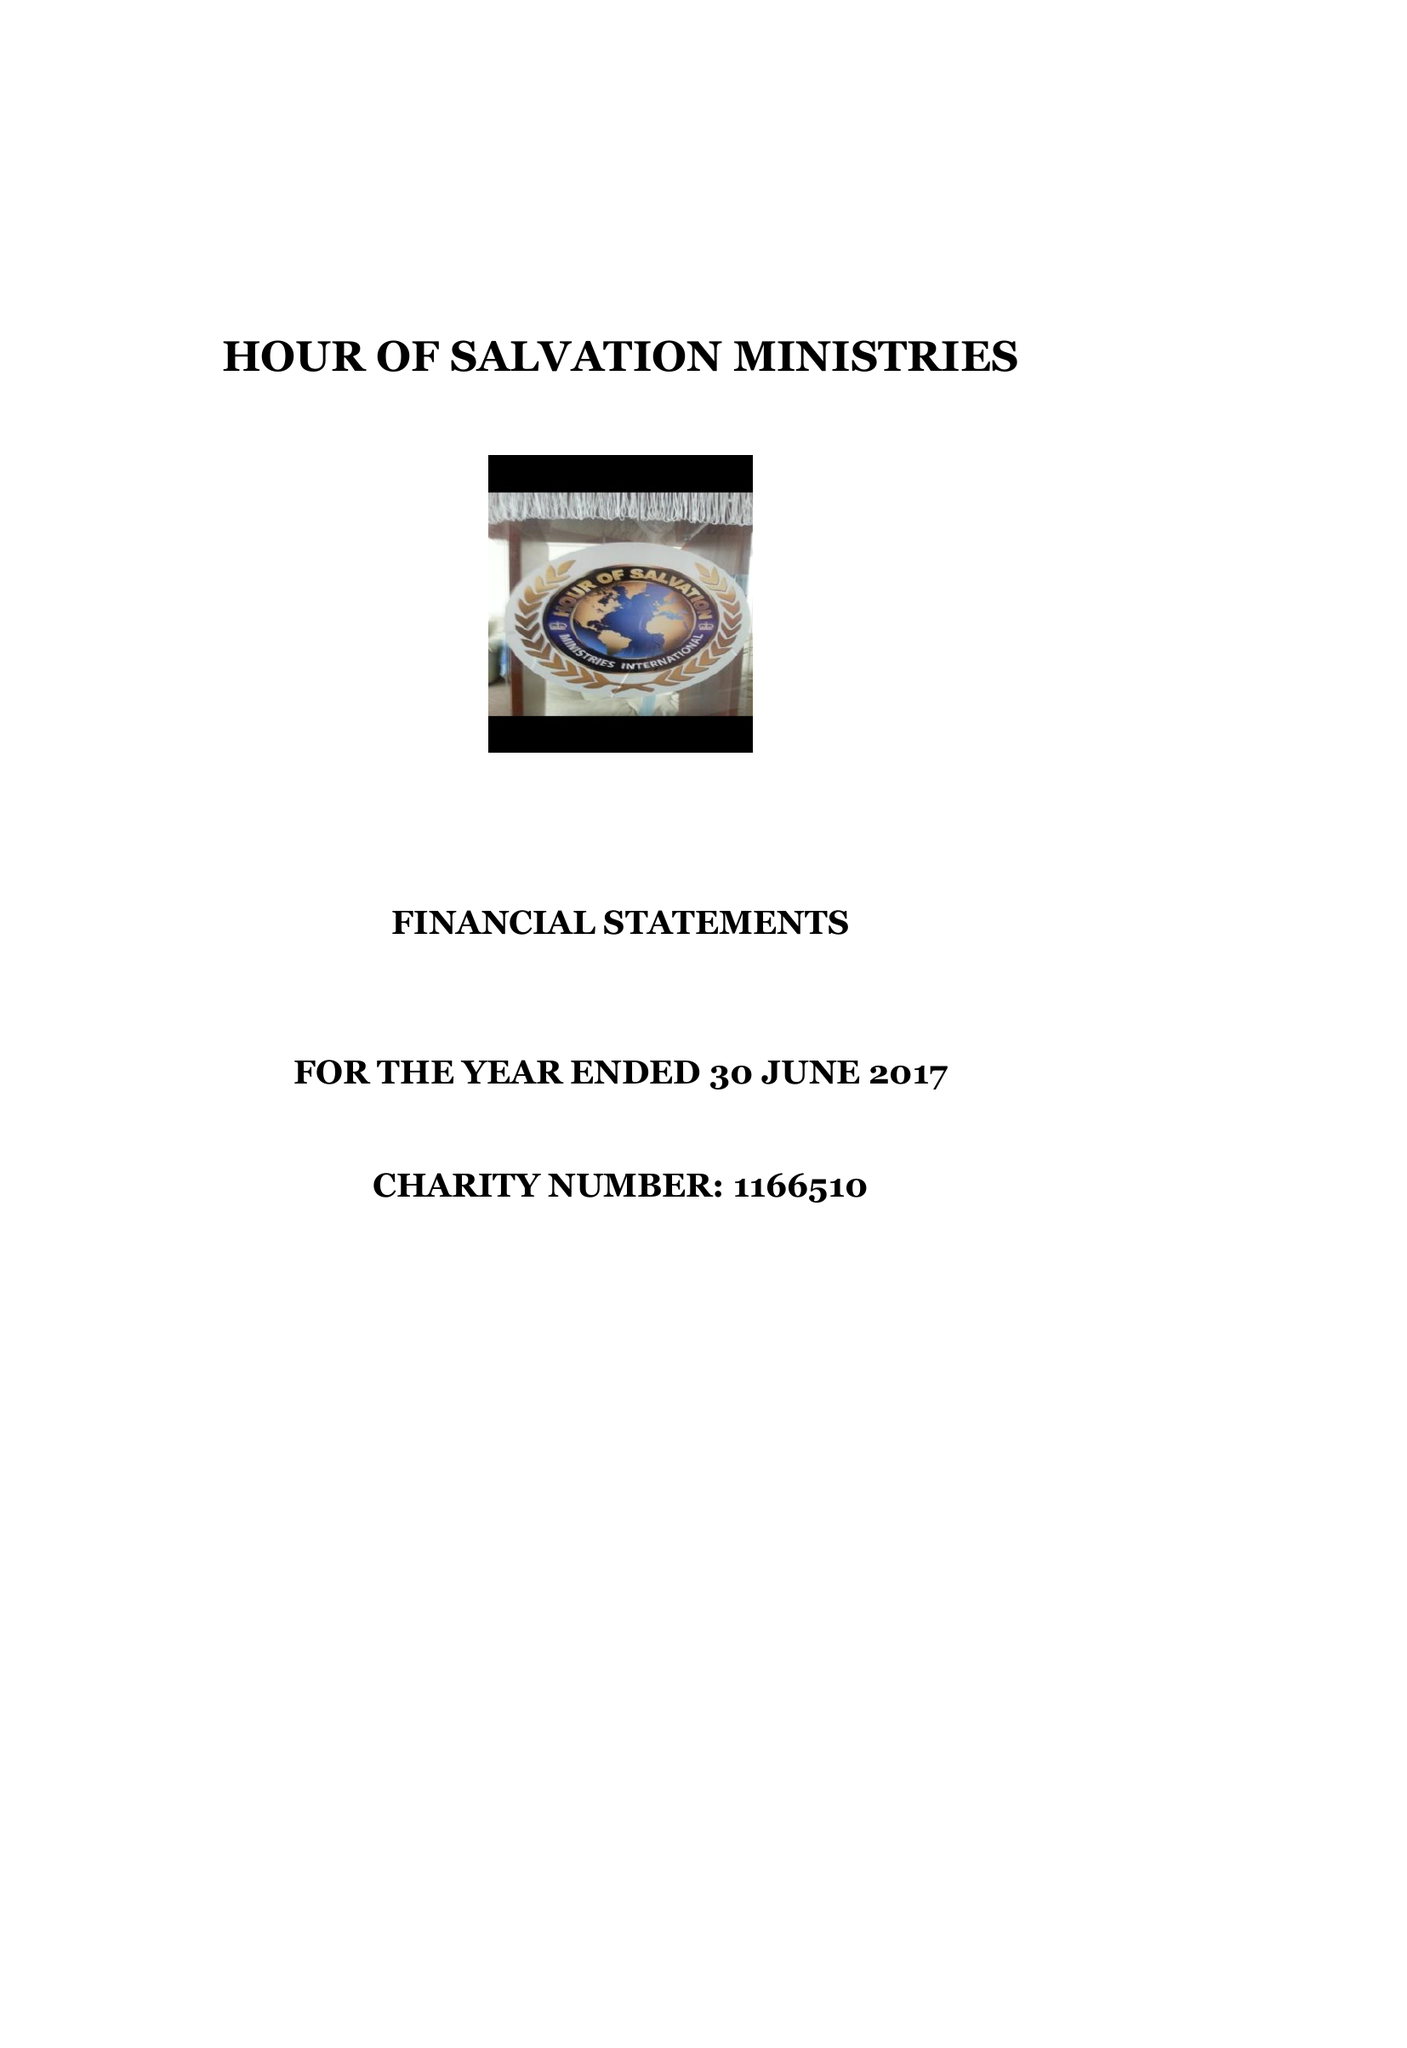What is the value for the address__postcode?
Answer the question using a single word or phrase. MK13 8NG 